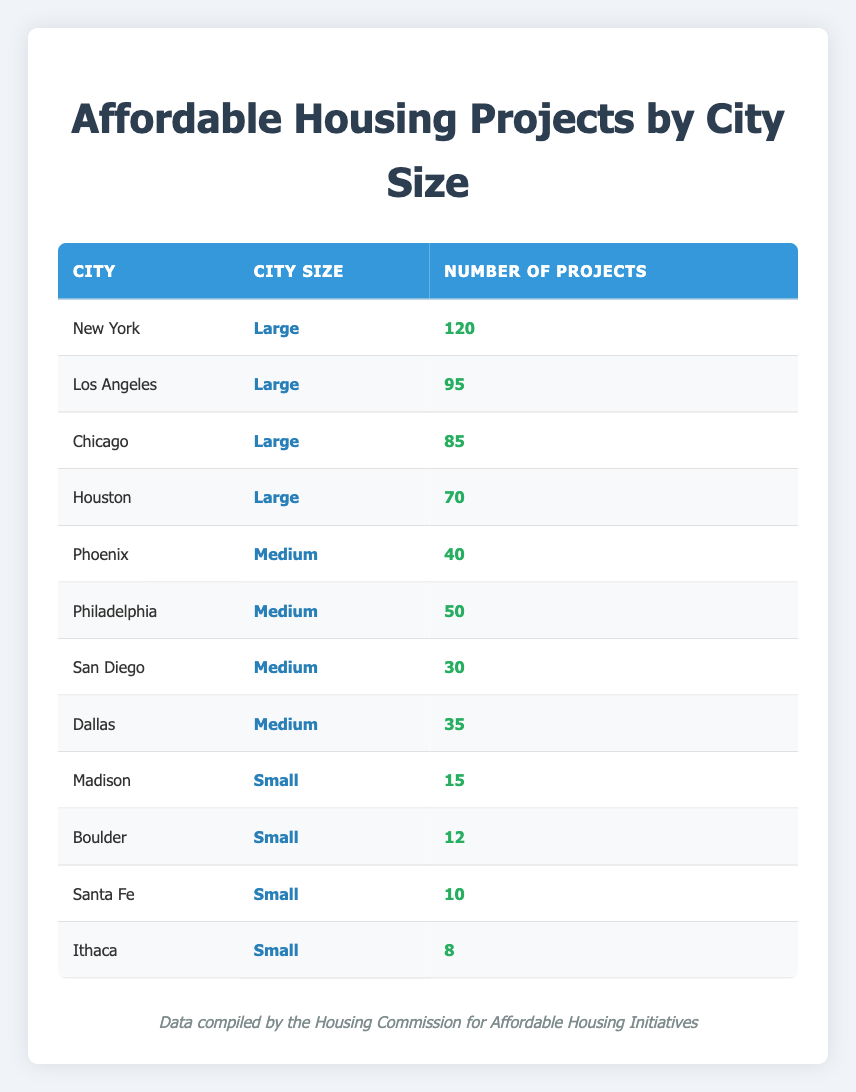What is the total number of affordable housing projects in large cities? To find the total number of affordable housing projects in large cities, I will sum the number of projects in each large city listed in the table: New York (120) + Los Angeles (95) + Chicago (85) + Houston (70) = 370.
Answer: 370 Which medium-sized city has the highest number of affordable housing projects? In the medium-sized city category, the cities listed are Phoenix (40), Philadelphia (50), San Diego (30), and Dallas (35). Among these figures, the highest is Philadelphia with 50 projects.
Answer: Philadelphia How many projects are there in small cities combined? To determine the number of projects in small cities, I will sum the number of projects from Madison (15), Boulder (12), Santa Fe (10), and Ithaca (8): 15 + 12 + 10 + 8 = 45.
Answer: 45 Is the number of affordable housing projects in Los Angeles greater than the number in Seattle? The table does not contain data for Seattle; therefore, it is not possible to compare Los Angeles's projects (95) with Seattle's nonexistent data. Thus, the answer is no.
Answer: No What is the average number of affordable housing projects in medium-sized cities? For medium-sized cities, the projects are 40 (Phoenix), 50 (Philadelphia), 30 (San Diego), and 35 (Dallas). First, sum them: 40 + 50 + 30 + 35 = 155. Then, divide by the number of medium cities (4): 155 / 4 = 38.75.
Answer: 38.75 In total, how many affordable housing projects are there across all city sizes? To find the total across all city sizes, sum projects from each category: large cities (370) + medium cities (155) + small cities (45) = 570.
Answer: 570 Are there more affordable housing projects in large cities than in small cities combined? The total for large cities is 370 and for small cities is 45. Since 370 is greater than 45, the answer is yes.
Answer: Yes Which small city has the least number of affordable housing projects? The small cities listed are Madison (15), Boulder (12), Santa Fe (10), and Ithaca (8). The least number of projects is in Ithaca with 8 projects.
Answer: Ithaca 